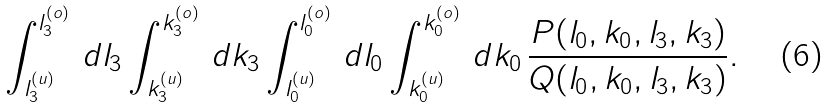<formula> <loc_0><loc_0><loc_500><loc_500>\int _ { l _ { 3 } ^ { ( u ) } } ^ { l _ { 3 } ^ { ( o ) } } \, d l _ { 3 } \int _ { k _ { 3 } ^ { ( u ) } } ^ { k _ { 3 } ^ { ( o ) } } \, d k _ { 3 } \int _ { l _ { 0 } ^ { ( u ) } } ^ { l _ { 0 } ^ { ( o ) } } \, d l _ { 0 } \int _ { k _ { 0 } ^ { ( u ) } } ^ { k _ { 0 } ^ { ( o ) } } \, d k _ { 0 } \, \frac { P ( l _ { 0 } , k _ { 0 } , l _ { 3 } , k _ { 3 } ) } { Q ( l _ { 0 } , k _ { 0 } , l _ { 3 } , k _ { 3 } ) } .</formula> 